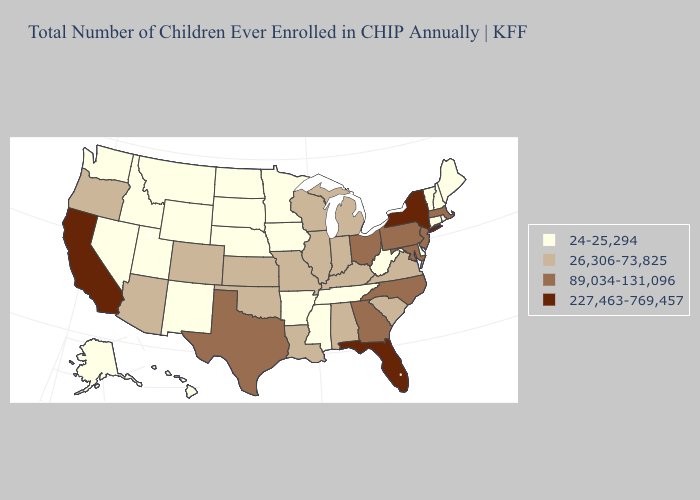Among the states that border Tennessee , does North Carolina have the highest value?
Give a very brief answer. Yes. Name the states that have a value in the range 24-25,294?
Quick response, please. Alaska, Arkansas, Connecticut, Delaware, Hawaii, Idaho, Iowa, Maine, Minnesota, Mississippi, Montana, Nebraska, Nevada, New Hampshire, New Mexico, North Dakota, Rhode Island, South Dakota, Tennessee, Utah, Vermont, Washington, West Virginia, Wyoming. What is the lowest value in states that border Iowa?
Keep it brief. 24-25,294. Does Indiana have the highest value in the MidWest?
Answer briefly. No. What is the value of Maryland?
Give a very brief answer. 89,034-131,096. Does New York have the highest value in the Northeast?
Concise answer only. Yes. Does the map have missing data?
Give a very brief answer. No. What is the value of Virginia?
Write a very short answer. 26,306-73,825. Is the legend a continuous bar?
Quick response, please. No. What is the lowest value in the USA?
Keep it brief. 24-25,294. Does New York have a higher value than Wisconsin?
Short answer required. Yes. What is the lowest value in the USA?
Write a very short answer. 24-25,294. Does New York have the highest value in the USA?
Answer briefly. Yes. Does the map have missing data?
Quick response, please. No. Among the states that border Montana , which have the lowest value?
Quick response, please. Idaho, North Dakota, South Dakota, Wyoming. 